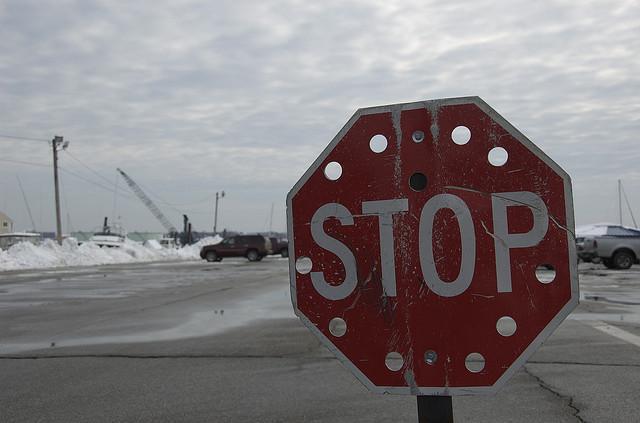How many people are holding signs?
Give a very brief answer. 0. 